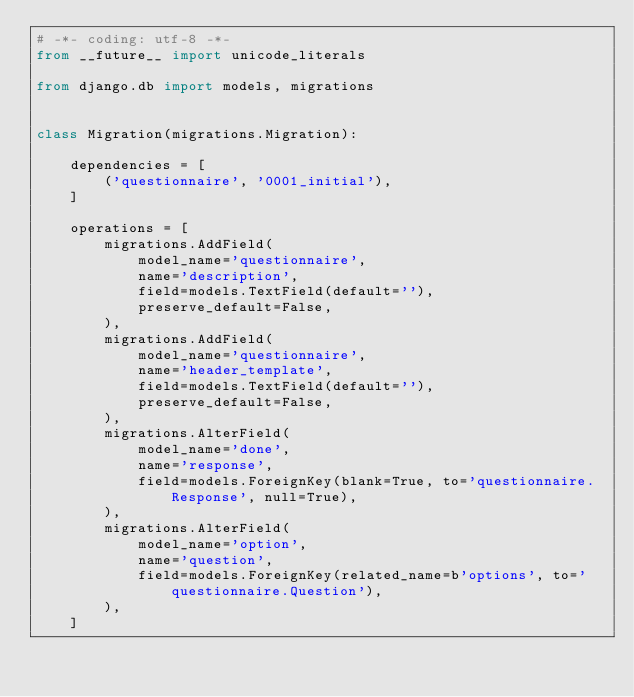<code> <loc_0><loc_0><loc_500><loc_500><_Python_># -*- coding: utf-8 -*-
from __future__ import unicode_literals

from django.db import models, migrations


class Migration(migrations.Migration):

    dependencies = [
        ('questionnaire', '0001_initial'),
    ]

    operations = [
        migrations.AddField(
            model_name='questionnaire',
            name='description',
            field=models.TextField(default=''),
            preserve_default=False,
        ),
        migrations.AddField(
            model_name='questionnaire',
            name='header_template',
            field=models.TextField(default=''),
            preserve_default=False,
        ),
        migrations.AlterField(
            model_name='done',
            name='response',
            field=models.ForeignKey(blank=True, to='questionnaire.Response', null=True),
        ),
        migrations.AlterField(
            model_name='option',
            name='question',
            field=models.ForeignKey(related_name=b'options', to='questionnaire.Question'),
        ),
    ]
</code> 